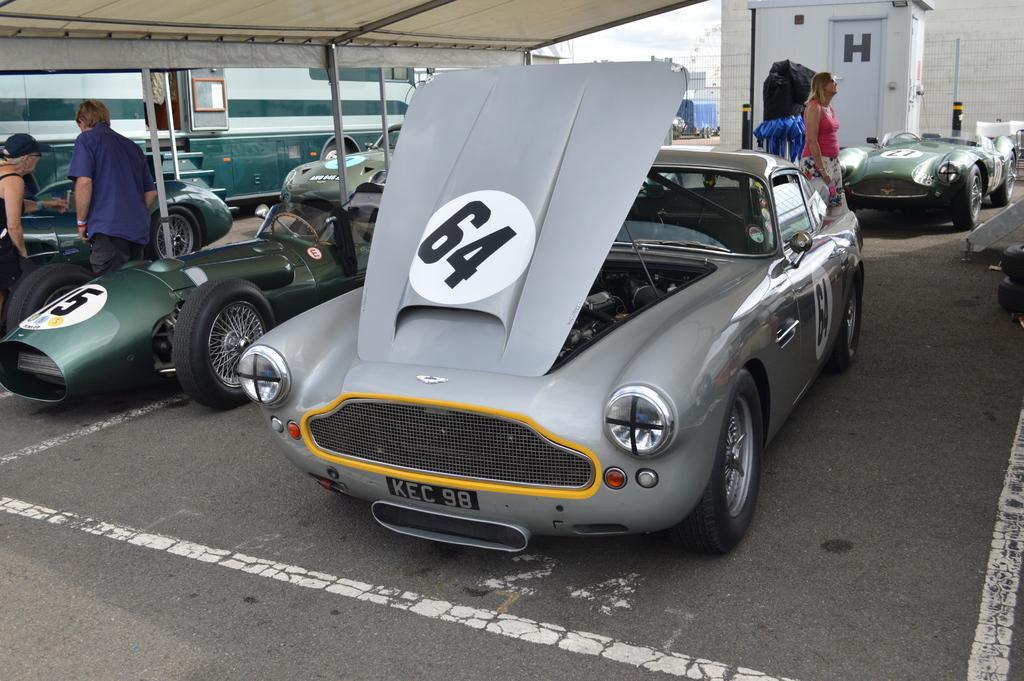How would you summarize this image in a sentence or two? In the foreground I can see fleets of cars, vehicle, group of people on the road. In the background I can see a fence, door, building, shed and the sky. This image is taken may be during a day. 